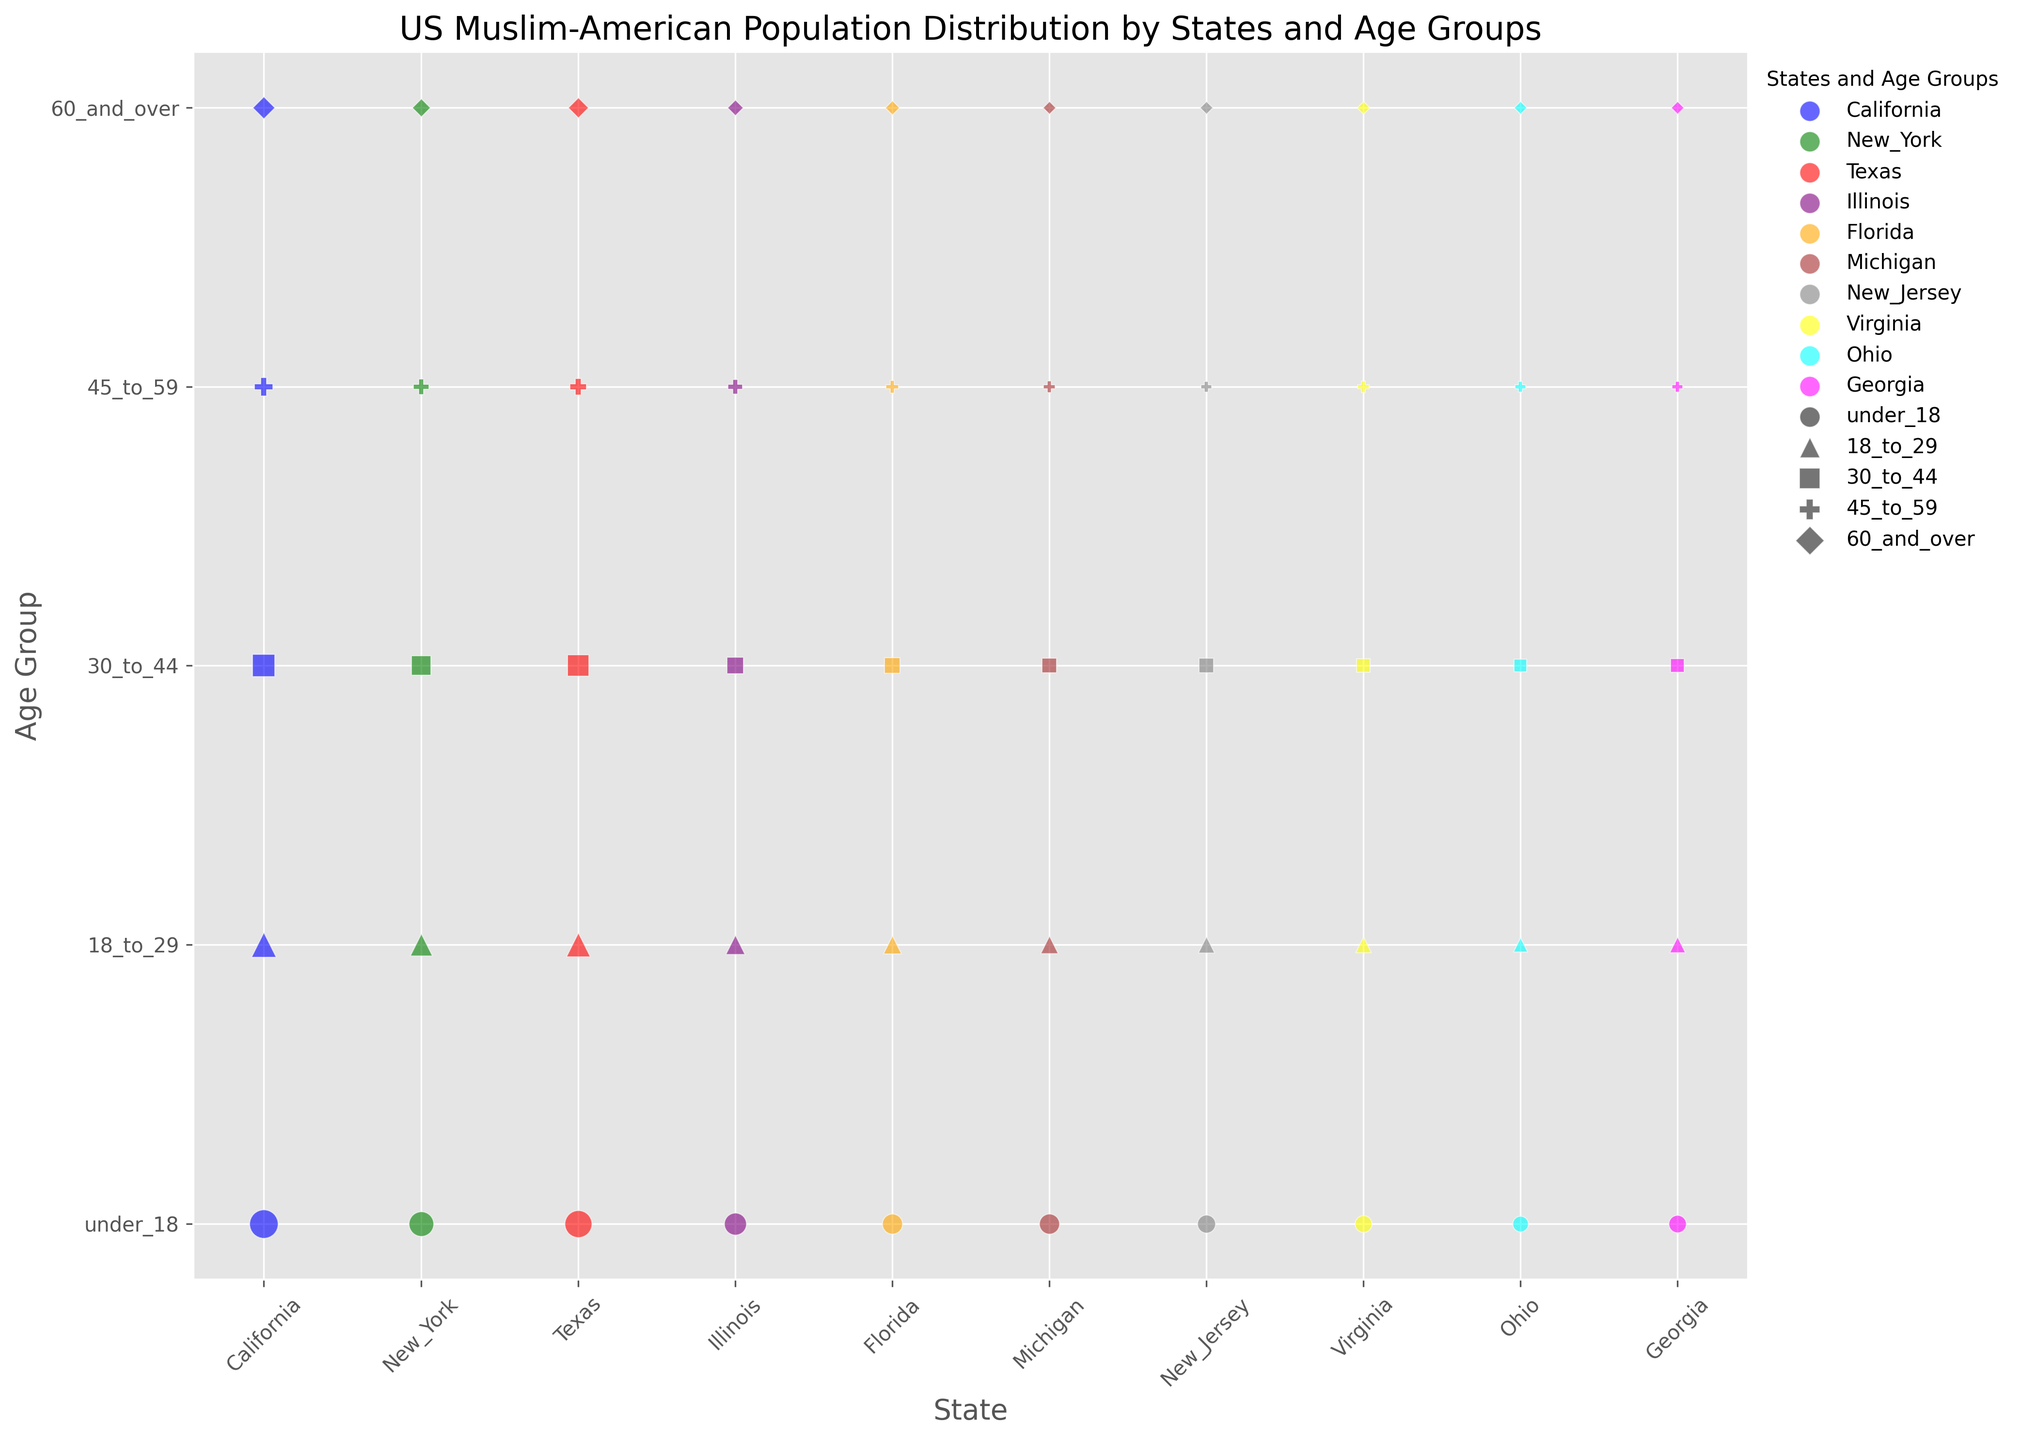which state has the highest population of Muslims in the 18_to_29 age group? To find this, look for the largest bubble corresponding to the 18_to_29 age group (marked with a ^ symbol) and compare the sizes for each state. Texas has the largest bubble for this age group.
Answer: Texas Which state has more Muslims aged 60_and_over, New York or Illinois? To answer this, compare the bubbles marked with a D symbol for New York and Illinois. New York has a larger bubble for the 60_and_over age group than Illinois.
Answer: New York What is the total population of Muslims under the age of 18 in California and Michigan combined? Find the bubbles marked 'under_18' (o symbol) for California and Michigan, sum their populations: 200,000 (California) + 100,000 (Michigan) = 300,000.
Answer: 300,000 Which state has the smallest Muslim population in the 45_to_59 age group? Look for the smallest bubble marked with a P symbol among the states. New Jersey and Ohio have the smallest bubbles for this age group, with equal size.
Answer: New Jersey, Ohio Compare the Michigan and Illinois Muslim populations in the 30_to_44 age group. Which state has more? Find the bubble marked with an s symbol for both Michigan and Illinois and compare their sizes. Illinois has a larger bubble than Michigan in this age group.
Answer: Illinois Which states have equal population sizes for the 60_and_over age group? Identify bubbles of equal sizes marked with a D symbol for this group. Michigan, New Jersey, Virginia, and Ohio have equal-sized bubbles for the 60_and_over age group.
Answer: Michigan, New Jersey, Virginia, Ohio How does the Muslim population of Florida aged 30_to_44 compare to that of Georgia? Compare the bubbles marked with an s symbol for both Florida and Georgia. Florida has a larger bubble than Georgia in this age group.
Answer: Florida Calculate the average Muslim population of the 45_to_59 age group across California, New York, and Texas. Sum the populations: 80,000 (California) + 60,000 (New York) + 70,000 (Texas) = 210,000. Divide by 3: 210,000 / 3 = 70,000.
Answer: 70,000 Which state has a higher ratio of Muslims under 18 to those aged 60_and_over, Virginia or Georgia? Calculate the ratios: Virginia: 70,000/20,000 = 3.5; Georgia: 75,000/20,000 = 3.75. Georgia has a higher ratio.
Answer: Georgia 